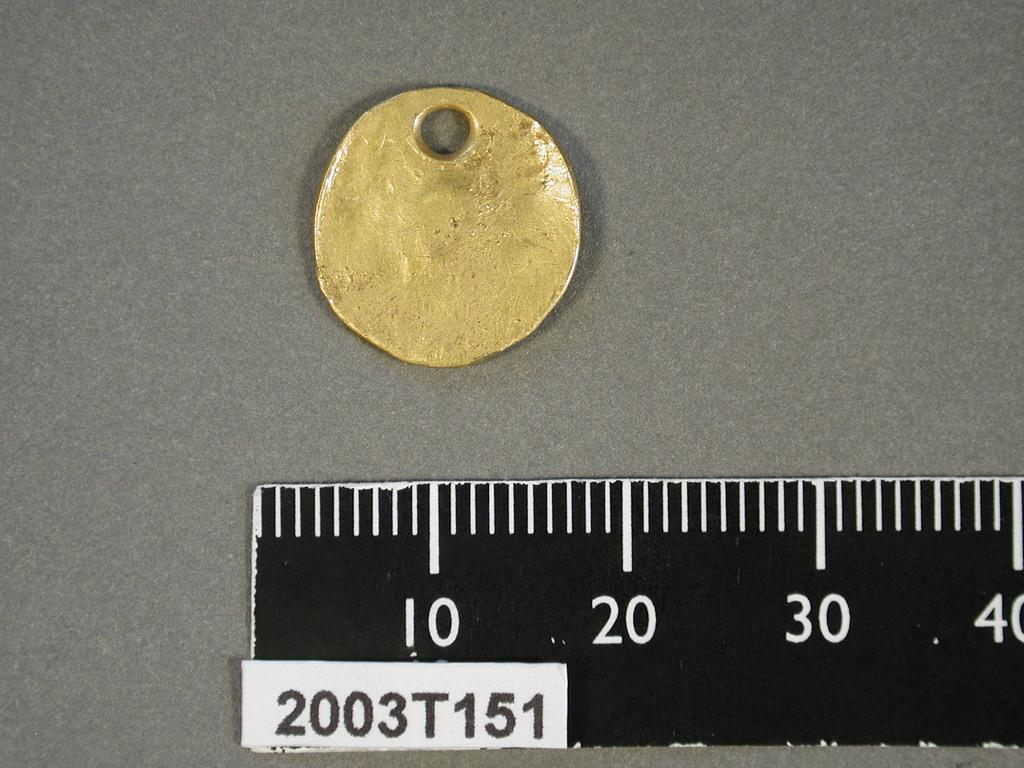<image>
Relay a brief, clear account of the picture shown. Ruler 2003T151 on a gray surface measuring a small gold coin. 